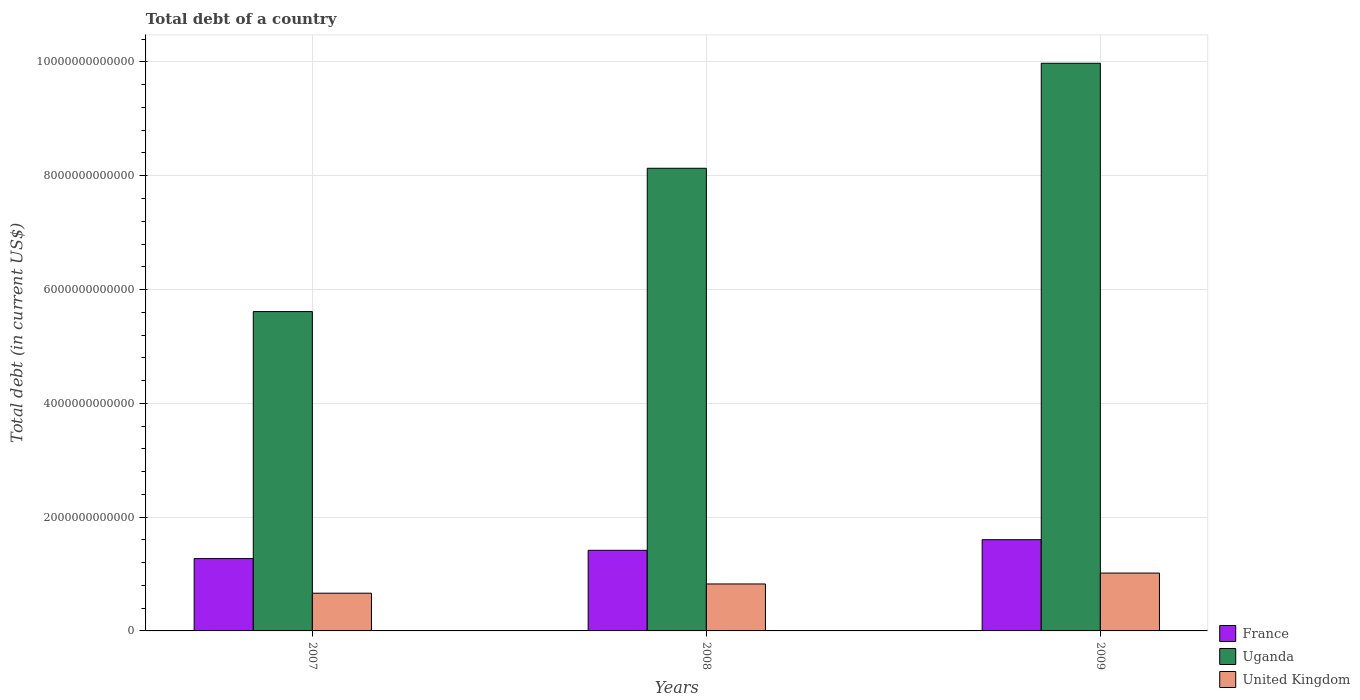Are the number of bars per tick equal to the number of legend labels?
Offer a very short reply. Yes. What is the label of the 1st group of bars from the left?
Give a very brief answer. 2007. What is the debt in Uganda in 2009?
Give a very brief answer. 9.98e+12. Across all years, what is the maximum debt in Uganda?
Ensure brevity in your answer.  9.98e+12. Across all years, what is the minimum debt in France?
Offer a terse response. 1.27e+12. In which year was the debt in Uganda maximum?
Ensure brevity in your answer.  2009. In which year was the debt in France minimum?
Ensure brevity in your answer.  2007. What is the total debt in United Kingdom in the graph?
Your response must be concise. 2.51e+12. What is the difference between the debt in United Kingdom in 2007 and that in 2009?
Your answer should be compact. -3.54e+11. What is the difference between the debt in Uganda in 2007 and the debt in United Kingdom in 2008?
Your answer should be very brief. 4.79e+12. What is the average debt in Uganda per year?
Your response must be concise. 7.91e+12. In the year 2009, what is the difference between the debt in United Kingdom and debt in France?
Provide a short and direct response. -5.87e+11. In how many years, is the debt in United Kingdom greater than 3200000000000 US$?
Offer a very short reply. 0. What is the ratio of the debt in Uganda in 2007 to that in 2008?
Provide a succinct answer. 0.69. What is the difference between the highest and the second highest debt in Uganda?
Provide a succinct answer. 1.85e+12. What is the difference between the highest and the lowest debt in France?
Provide a short and direct response. 3.31e+11. What does the 2nd bar from the left in 2009 represents?
Your answer should be compact. Uganda. How many bars are there?
Provide a short and direct response. 9. Are all the bars in the graph horizontal?
Offer a very short reply. No. How many years are there in the graph?
Provide a short and direct response. 3. What is the difference between two consecutive major ticks on the Y-axis?
Offer a terse response. 2.00e+12. Are the values on the major ticks of Y-axis written in scientific E-notation?
Give a very brief answer. No. Does the graph contain grids?
Give a very brief answer. Yes. Where does the legend appear in the graph?
Provide a short and direct response. Bottom right. How are the legend labels stacked?
Your answer should be compact. Vertical. What is the title of the graph?
Give a very brief answer. Total debt of a country. What is the label or title of the X-axis?
Offer a very short reply. Years. What is the label or title of the Y-axis?
Ensure brevity in your answer.  Total debt (in current US$). What is the Total debt (in current US$) in France in 2007?
Give a very brief answer. 1.27e+12. What is the Total debt (in current US$) in Uganda in 2007?
Make the answer very short. 5.61e+12. What is the Total debt (in current US$) of United Kingdom in 2007?
Ensure brevity in your answer.  6.63e+11. What is the Total debt (in current US$) of France in 2008?
Offer a terse response. 1.42e+12. What is the Total debt (in current US$) in Uganda in 2008?
Ensure brevity in your answer.  8.13e+12. What is the Total debt (in current US$) of United Kingdom in 2008?
Provide a succinct answer. 8.25e+11. What is the Total debt (in current US$) of France in 2009?
Give a very brief answer. 1.60e+12. What is the Total debt (in current US$) in Uganda in 2009?
Keep it short and to the point. 9.98e+12. What is the Total debt (in current US$) of United Kingdom in 2009?
Provide a succinct answer. 1.02e+12. Across all years, what is the maximum Total debt (in current US$) of France?
Your answer should be compact. 1.60e+12. Across all years, what is the maximum Total debt (in current US$) of Uganda?
Offer a very short reply. 9.98e+12. Across all years, what is the maximum Total debt (in current US$) in United Kingdom?
Keep it short and to the point. 1.02e+12. Across all years, what is the minimum Total debt (in current US$) in France?
Your response must be concise. 1.27e+12. Across all years, what is the minimum Total debt (in current US$) in Uganda?
Your answer should be very brief. 5.61e+12. Across all years, what is the minimum Total debt (in current US$) in United Kingdom?
Offer a very short reply. 6.63e+11. What is the total Total debt (in current US$) of France in the graph?
Your answer should be compact. 4.29e+12. What is the total Total debt (in current US$) of Uganda in the graph?
Your answer should be very brief. 2.37e+13. What is the total Total debt (in current US$) of United Kingdom in the graph?
Your answer should be compact. 2.51e+12. What is the difference between the Total debt (in current US$) of France in 2007 and that in 2008?
Provide a succinct answer. -1.45e+11. What is the difference between the Total debt (in current US$) of Uganda in 2007 and that in 2008?
Ensure brevity in your answer.  -2.52e+12. What is the difference between the Total debt (in current US$) in United Kingdom in 2007 and that in 2008?
Provide a short and direct response. -1.62e+11. What is the difference between the Total debt (in current US$) in France in 2007 and that in 2009?
Your answer should be compact. -3.31e+11. What is the difference between the Total debt (in current US$) in Uganda in 2007 and that in 2009?
Provide a succinct answer. -4.36e+12. What is the difference between the Total debt (in current US$) in United Kingdom in 2007 and that in 2009?
Your answer should be very brief. -3.54e+11. What is the difference between the Total debt (in current US$) of France in 2008 and that in 2009?
Give a very brief answer. -1.86e+11. What is the difference between the Total debt (in current US$) of Uganda in 2008 and that in 2009?
Your answer should be very brief. -1.85e+12. What is the difference between the Total debt (in current US$) in United Kingdom in 2008 and that in 2009?
Keep it short and to the point. -1.91e+11. What is the difference between the Total debt (in current US$) of France in 2007 and the Total debt (in current US$) of Uganda in 2008?
Your answer should be compact. -6.86e+12. What is the difference between the Total debt (in current US$) of France in 2007 and the Total debt (in current US$) of United Kingdom in 2008?
Your response must be concise. 4.47e+11. What is the difference between the Total debt (in current US$) of Uganda in 2007 and the Total debt (in current US$) of United Kingdom in 2008?
Ensure brevity in your answer.  4.79e+12. What is the difference between the Total debt (in current US$) of France in 2007 and the Total debt (in current US$) of Uganda in 2009?
Keep it short and to the point. -8.71e+12. What is the difference between the Total debt (in current US$) in France in 2007 and the Total debt (in current US$) in United Kingdom in 2009?
Keep it short and to the point. 2.55e+11. What is the difference between the Total debt (in current US$) in Uganda in 2007 and the Total debt (in current US$) in United Kingdom in 2009?
Make the answer very short. 4.60e+12. What is the difference between the Total debt (in current US$) in France in 2008 and the Total debt (in current US$) in Uganda in 2009?
Offer a very short reply. -8.56e+12. What is the difference between the Total debt (in current US$) in France in 2008 and the Total debt (in current US$) in United Kingdom in 2009?
Make the answer very short. 4.00e+11. What is the difference between the Total debt (in current US$) in Uganda in 2008 and the Total debt (in current US$) in United Kingdom in 2009?
Your answer should be very brief. 7.11e+12. What is the average Total debt (in current US$) of France per year?
Provide a short and direct response. 1.43e+12. What is the average Total debt (in current US$) in Uganda per year?
Provide a succinct answer. 7.91e+12. What is the average Total debt (in current US$) in United Kingdom per year?
Make the answer very short. 8.35e+11. In the year 2007, what is the difference between the Total debt (in current US$) of France and Total debt (in current US$) of Uganda?
Your answer should be very brief. -4.34e+12. In the year 2007, what is the difference between the Total debt (in current US$) of France and Total debt (in current US$) of United Kingdom?
Make the answer very short. 6.09e+11. In the year 2007, what is the difference between the Total debt (in current US$) of Uganda and Total debt (in current US$) of United Kingdom?
Your answer should be compact. 4.95e+12. In the year 2008, what is the difference between the Total debt (in current US$) of France and Total debt (in current US$) of Uganda?
Ensure brevity in your answer.  -6.71e+12. In the year 2008, what is the difference between the Total debt (in current US$) of France and Total debt (in current US$) of United Kingdom?
Ensure brevity in your answer.  5.92e+11. In the year 2008, what is the difference between the Total debt (in current US$) in Uganda and Total debt (in current US$) in United Kingdom?
Offer a terse response. 7.31e+12. In the year 2009, what is the difference between the Total debt (in current US$) of France and Total debt (in current US$) of Uganda?
Give a very brief answer. -8.37e+12. In the year 2009, what is the difference between the Total debt (in current US$) of France and Total debt (in current US$) of United Kingdom?
Your response must be concise. 5.87e+11. In the year 2009, what is the difference between the Total debt (in current US$) of Uganda and Total debt (in current US$) of United Kingdom?
Ensure brevity in your answer.  8.96e+12. What is the ratio of the Total debt (in current US$) of France in 2007 to that in 2008?
Provide a short and direct response. 0.9. What is the ratio of the Total debt (in current US$) in Uganda in 2007 to that in 2008?
Your answer should be compact. 0.69. What is the ratio of the Total debt (in current US$) of United Kingdom in 2007 to that in 2008?
Make the answer very short. 0.8. What is the ratio of the Total debt (in current US$) in France in 2007 to that in 2009?
Your answer should be very brief. 0.79. What is the ratio of the Total debt (in current US$) in Uganda in 2007 to that in 2009?
Your answer should be compact. 0.56. What is the ratio of the Total debt (in current US$) of United Kingdom in 2007 to that in 2009?
Provide a succinct answer. 0.65. What is the ratio of the Total debt (in current US$) of France in 2008 to that in 2009?
Your response must be concise. 0.88. What is the ratio of the Total debt (in current US$) in Uganda in 2008 to that in 2009?
Offer a very short reply. 0.81. What is the ratio of the Total debt (in current US$) of United Kingdom in 2008 to that in 2009?
Provide a short and direct response. 0.81. What is the difference between the highest and the second highest Total debt (in current US$) in France?
Offer a very short reply. 1.86e+11. What is the difference between the highest and the second highest Total debt (in current US$) in Uganda?
Offer a very short reply. 1.85e+12. What is the difference between the highest and the second highest Total debt (in current US$) in United Kingdom?
Give a very brief answer. 1.91e+11. What is the difference between the highest and the lowest Total debt (in current US$) of France?
Your answer should be very brief. 3.31e+11. What is the difference between the highest and the lowest Total debt (in current US$) of Uganda?
Keep it short and to the point. 4.36e+12. What is the difference between the highest and the lowest Total debt (in current US$) in United Kingdom?
Keep it short and to the point. 3.54e+11. 